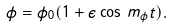<formula> <loc_0><loc_0><loc_500><loc_500>\phi = \phi _ { 0 } ( 1 + \epsilon \cos \, m _ { \phi } t ) .</formula> 